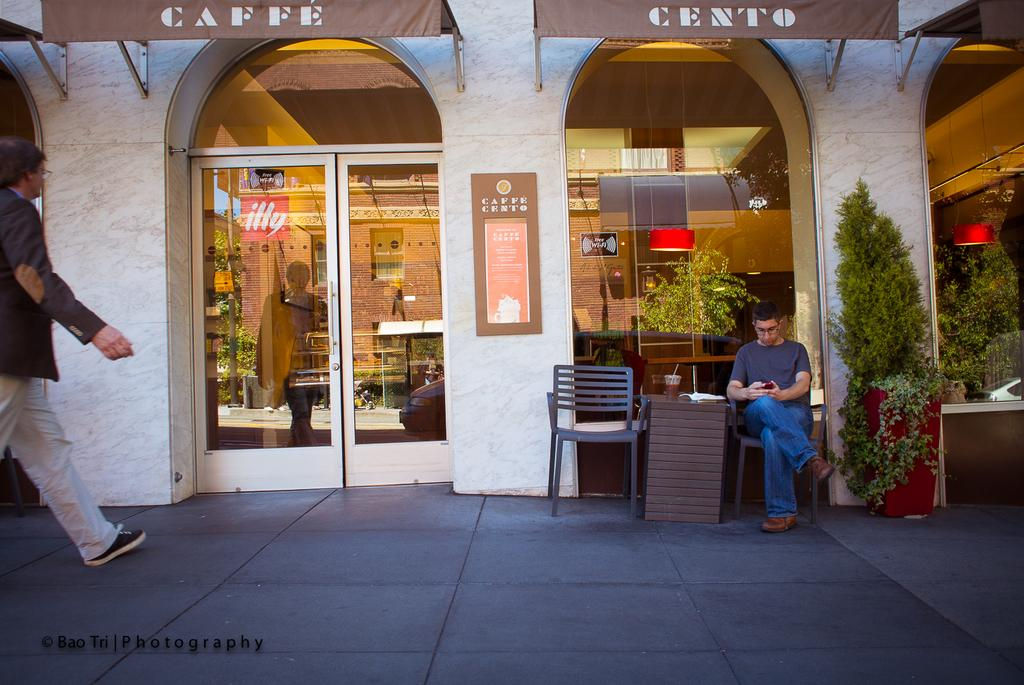What is the man in the image doing? There is a man sitting on a chair in the image. What object is on the table in the image? There is a glass on a table in the image. What is happening on the left side of the image? A man is walking on the left side of the image. What type of structure can be seen in the image? There is a building visible in the image. What is present near the building? There is a flower pot in the image. Can you tell me how many beetles are crawling on the flower pot in the image? There are no beetles present on the flower pot in the image. What type of arch can be seen in the image? There is no arch present in the image. 